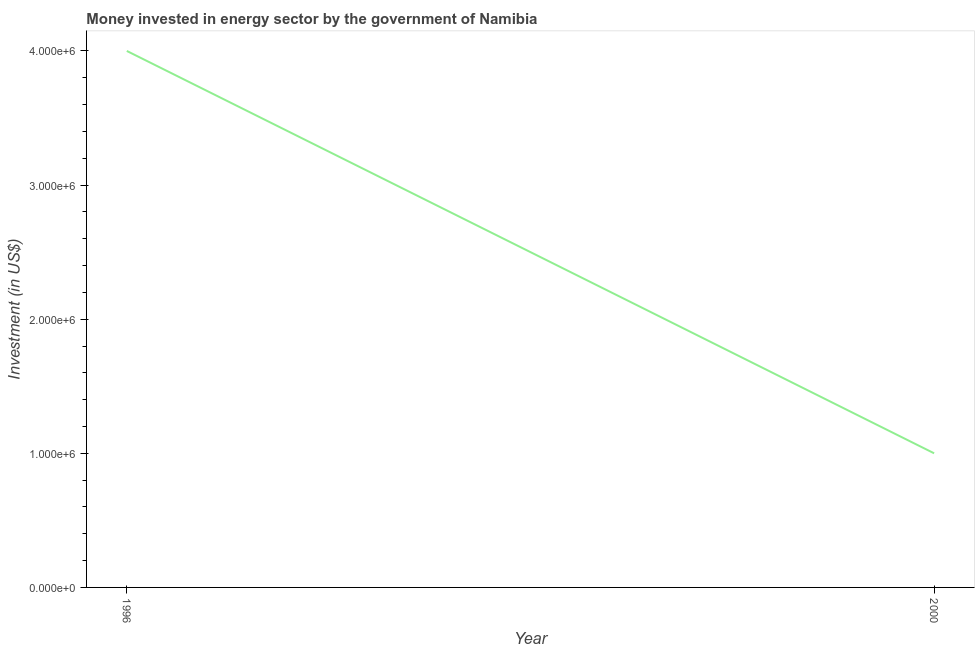What is the investment in energy in 2000?
Keep it short and to the point. 1.00e+06. Across all years, what is the maximum investment in energy?
Your answer should be compact. 4.00e+06. Across all years, what is the minimum investment in energy?
Give a very brief answer. 1.00e+06. In which year was the investment in energy maximum?
Your answer should be very brief. 1996. In which year was the investment in energy minimum?
Your answer should be very brief. 2000. What is the sum of the investment in energy?
Provide a succinct answer. 5.00e+06. What is the difference between the investment in energy in 1996 and 2000?
Offer a terse response. 3.00e+06. What is the average investment in energy per year?
Your answer should be very brief. 2.50e+06. What is the median investment in energy?
Offer a terse response. 2.50e+06. Do a majority of the years between 1996 and 2000 (inclusive) have investment in energy greater than 2000000 US$?
Give a very brief answer. No. In how many years, is the investment in energy greater than the average investment in energy taken over all years?
Your answer should be compact. 1. How many years are there in the graph?
Keep it short and to the point. 2. What is the difference between two consecutive major ticks on the Y-axis?
Your response must be concise. 1.00e+06. Are the values on the major ticks of Y-axis written in scientific E-notation?
Give a very brief answer. Yes. Does the graph contain grids?
Ensure brevity in your answer.  No. What is the title of the graph?
Give a very brief answer. Money invested in energy sector by the government of Namibia. What is the label or title of the Y-axis?
Offer a very short reply. Investment (in US$). What is the Investment (in US$) in 1996?
Your response must be concise. 4.00e+06. What is the Investment (in US$) of 2000?
Provide a short and direct response. 1.00e+06. 